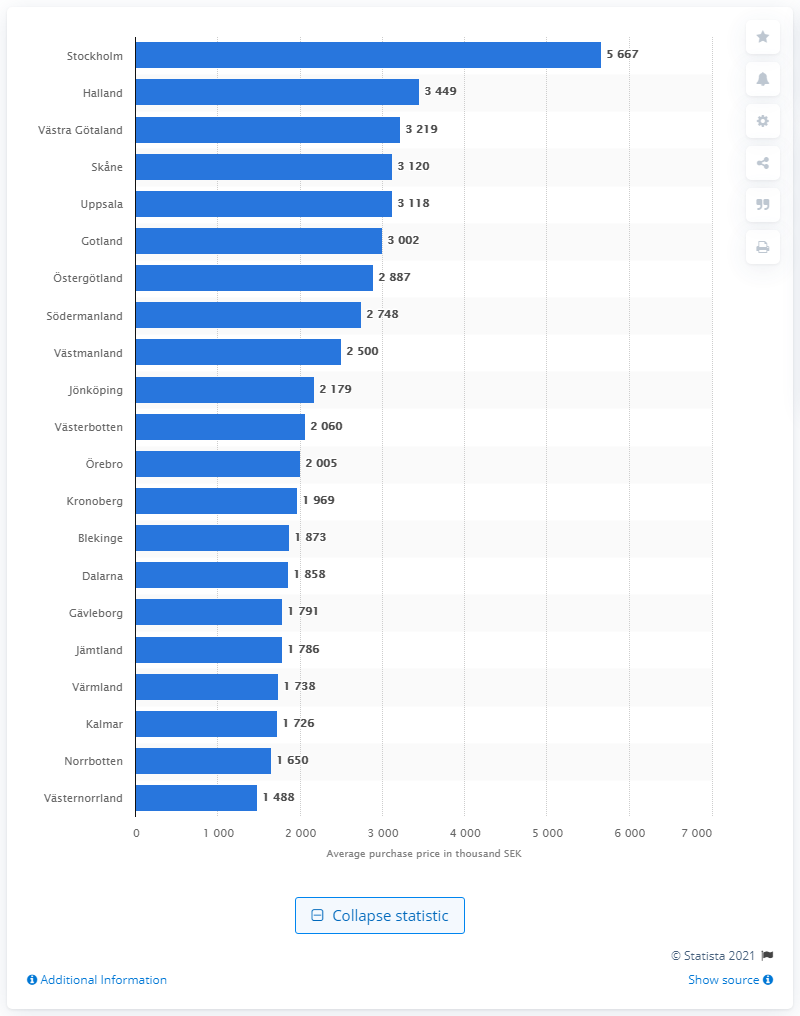Where was the highest average purchase price for one- and two-residential property in Sweden in 2019? In 2019, Stockholm had the highest average purchase price for one- and two-bedroom residential properties in Sweden, reaching up to 5,667 thousand SEK. 